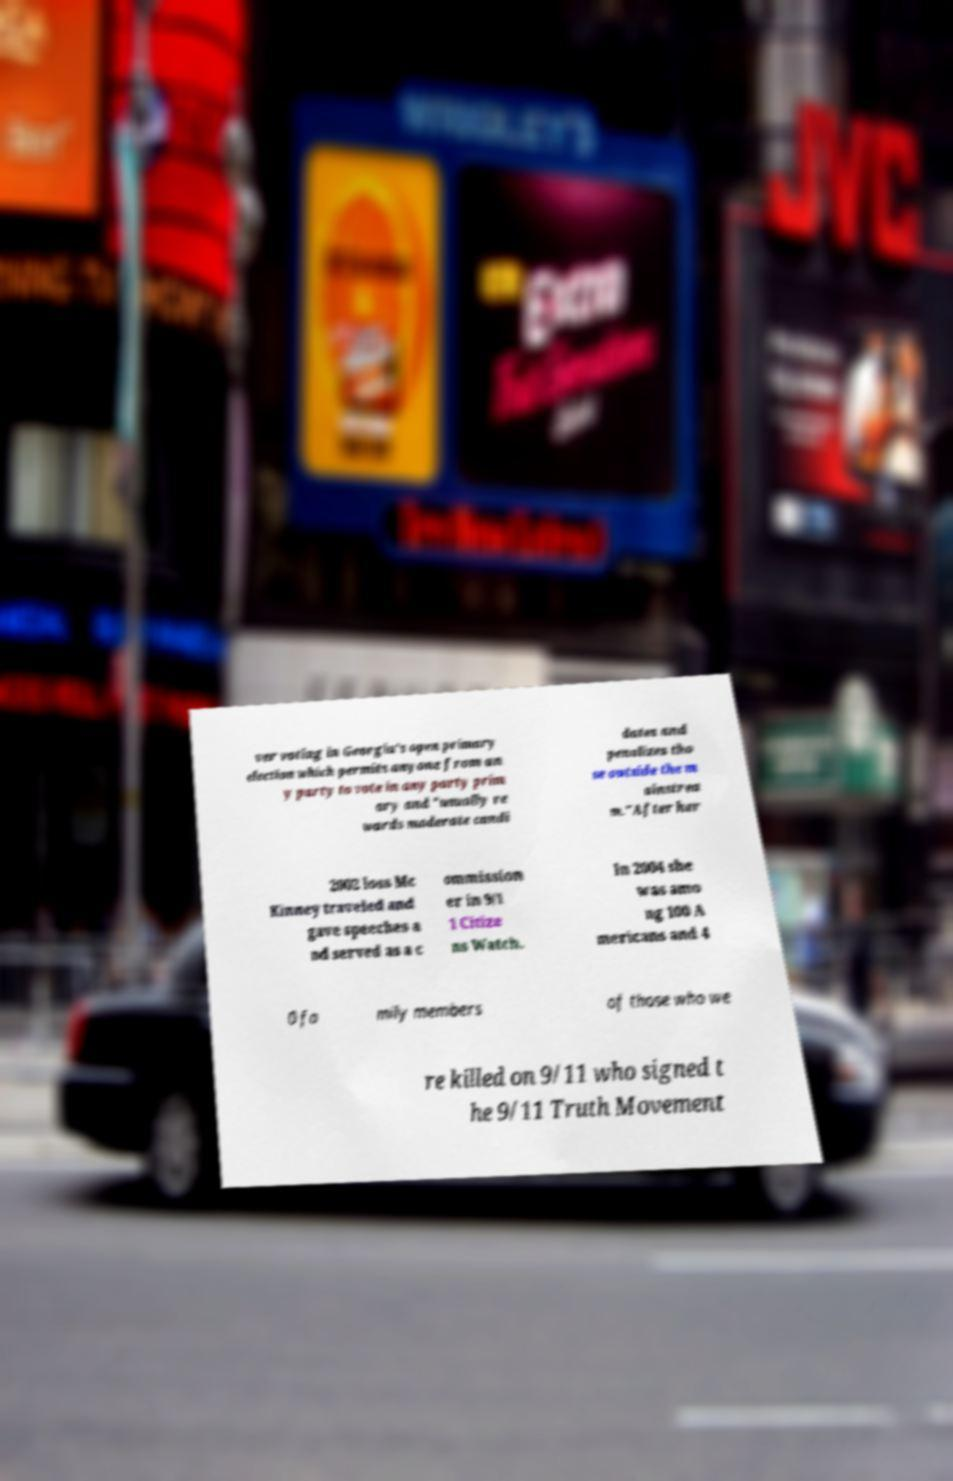Could you extract and type out the text from this image? ver voting in Georgia's open primary election which permits anyone from an y party to vote in any party prim ary and "usually re wards moderate candi dates and penalizes tho se outside the m ainstrea m."After her 2002 loss Mc Kinney traveled and gave speeches a nd served as a c ommission er in 9/1 1 Citize ns Watch. In 2004 she was amo ng 100 A mericans and 4 0 fa mily members of those who we re killed on 9/11 who signed t he 9/11 Truth Movement 